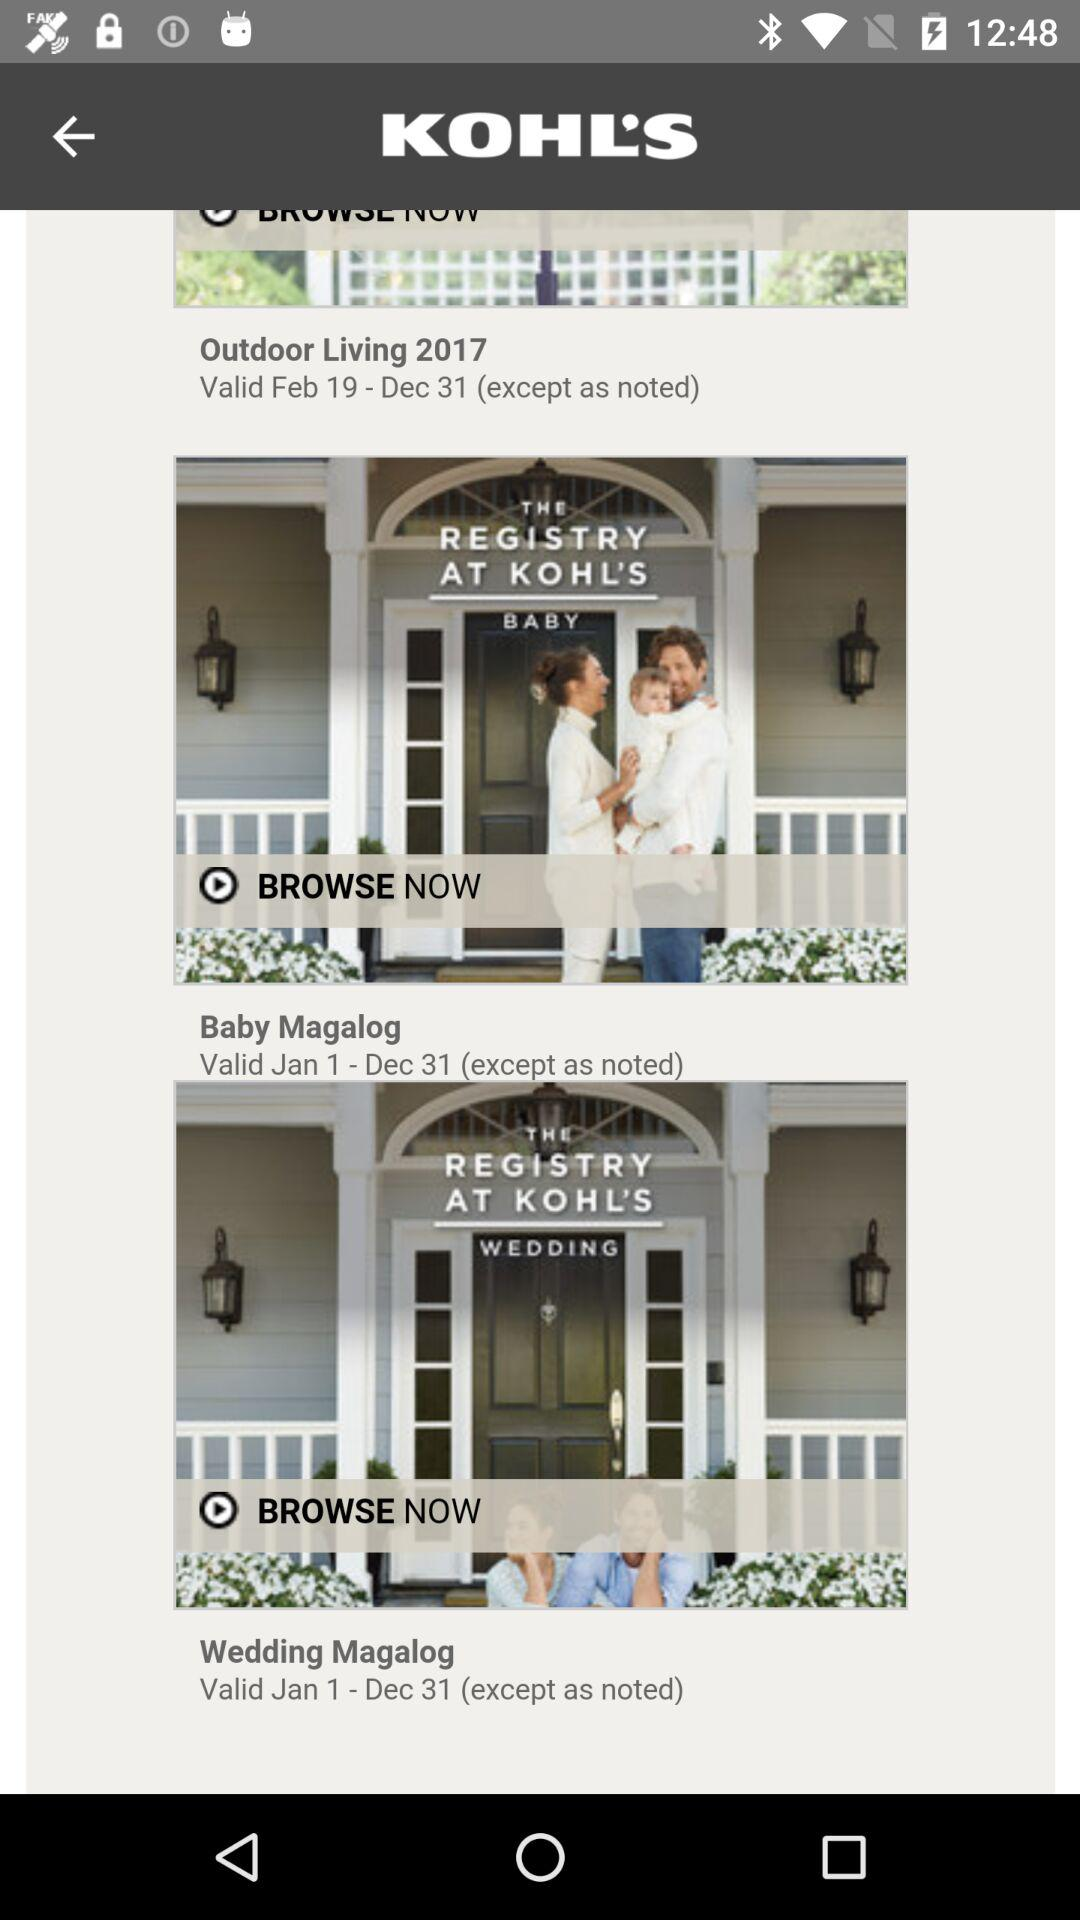How many of the three items have a valid date range of Jan 1 - Dec 31?
Answer the question using a single word or phrase. 2 